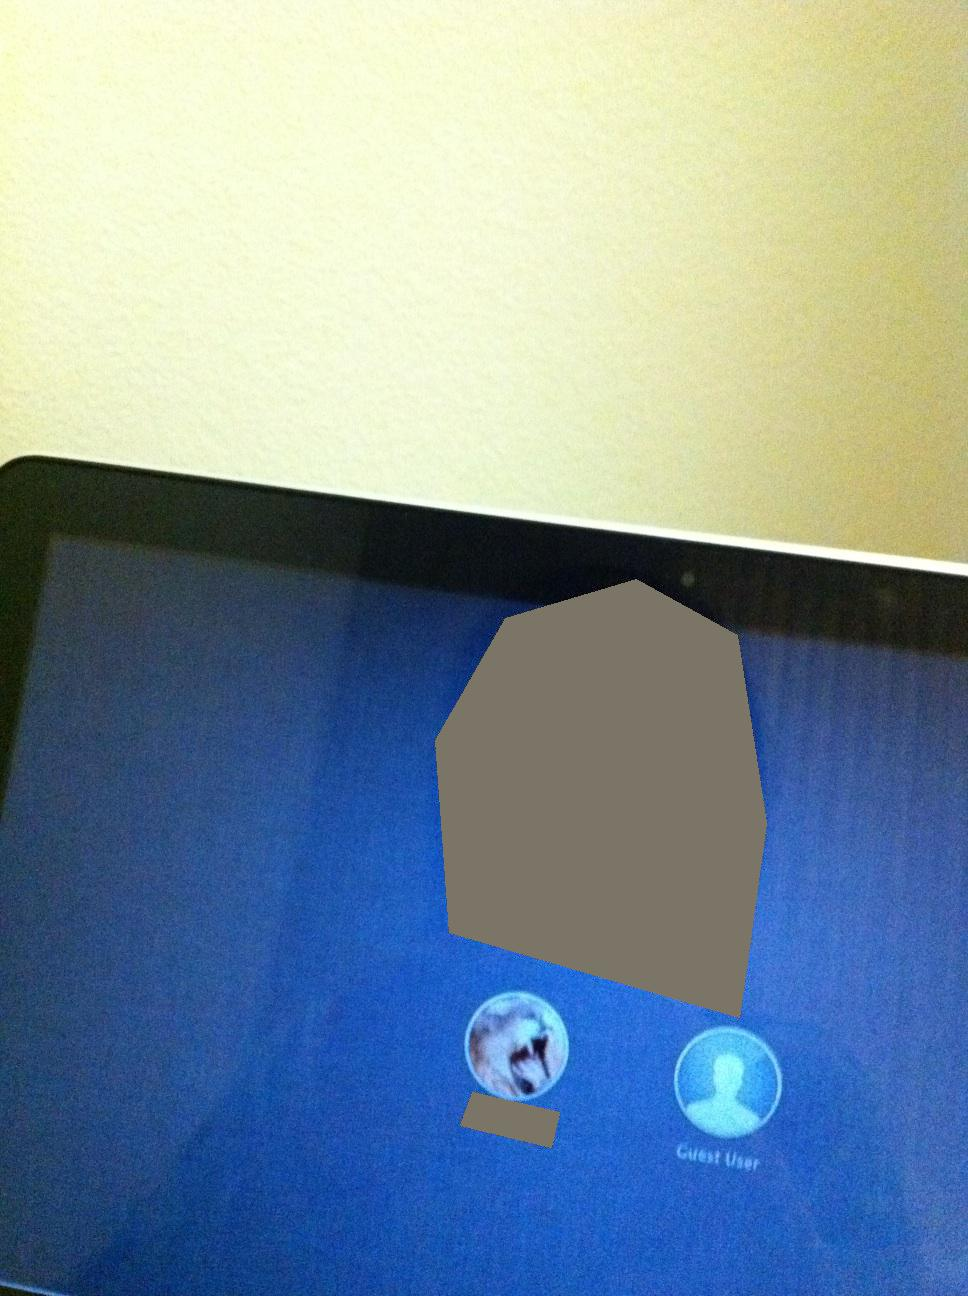Imagine you had to describe the scene to someone who cannot see it. How would you describe it? The scene shows a computer screen that is at an angle. The screen displays a login interface with a blue background. At the center of the screen, there are two icons: one on the left that has a picture and one on the right labeled 'Guest User'. 